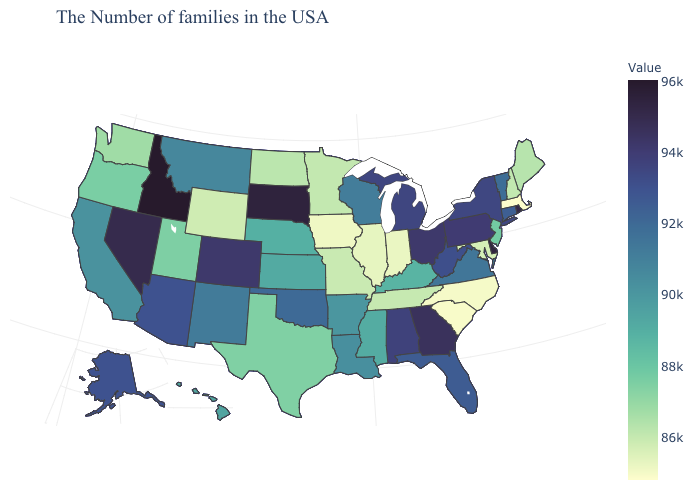Among the states that border Wyoming , which have the highest value?
Answer briefly. Idaho. Among the states that border Texas , which have the highest value?
Quick response, please. Oklahoma. Among the states that border Connecticut , which have the highest value?
Give a very brief answer. Rhode Island. Does Delaware have a lower value than Utah?
Give a very brief answer. No. Among the states that border Montana , does South Dakota have the highest value?
Answer briefly. No. Does South Carolina have the lowest value in the South?
Be succinct. Yes. 